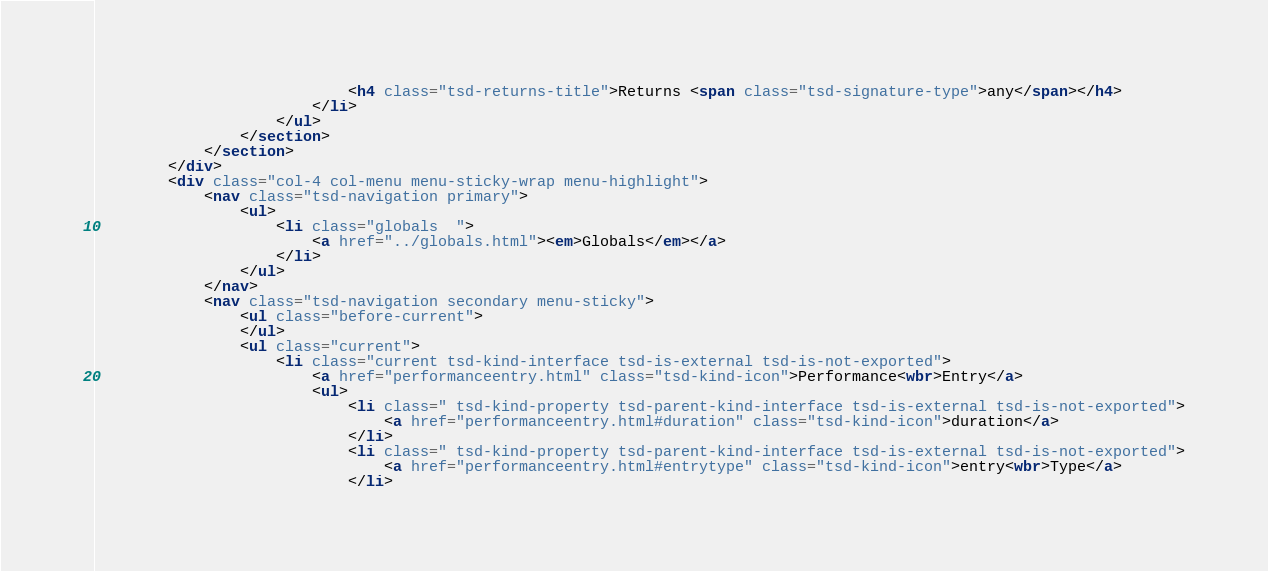<code> <loc_0><loc_0><loc_500><loc_500><_HTML_>							<h4 class="tsd-returns-title">Returns <span class="tsd-signature-type">any</span></h4>
						</li>
					</ul>
				</section>
			</section>
		</div>
		<div class="col-4 col-menu menu-sticky-wrap menu-highlight">
			<nav class="tsd-navigation primary">
				<ul>
					<li class="globals  ">
						<a href="../globals.html"><em>Globals</em></a>
					</li>
				</ul>
			</nav>
			<nav class="tsd-navigation secondary menu-sticky">
				<ul class="before-current">
				</ul>
				<ul class="current">
					<li class="current tsd-kind-interface tsd-is-external tsd-is-not-exported">
						<a href="performanceentry.html" class="tsd-kind-icon">Performance<wbr>Entry</a>
						<ul>
							<li class=" tsd-kind-property tsd-parent-kind-interface tsd-is-external tsd-is-not-exported">
								<a href="performanceentry.html#duration" class="tsd-kind-icon">duration</a>
							</li>
							<li class=" tsd-kind-property tsd-parent-kind-interface tsd-is-external tsd-is-not-exported">
								<a href="performanceentry.html#entrytype" class="tsd-kind-icon">entry<wbr>Type</a>
							</li></code> 